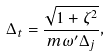<formula> <loc_0><loc_0><loc_500><loc_500>\Delta _ { t } = \frac { \sqrt { 1 + \zeta ^ { 2 } } } { m \omega ^ { \prime } \Delta _ { j } } ,</formula> 